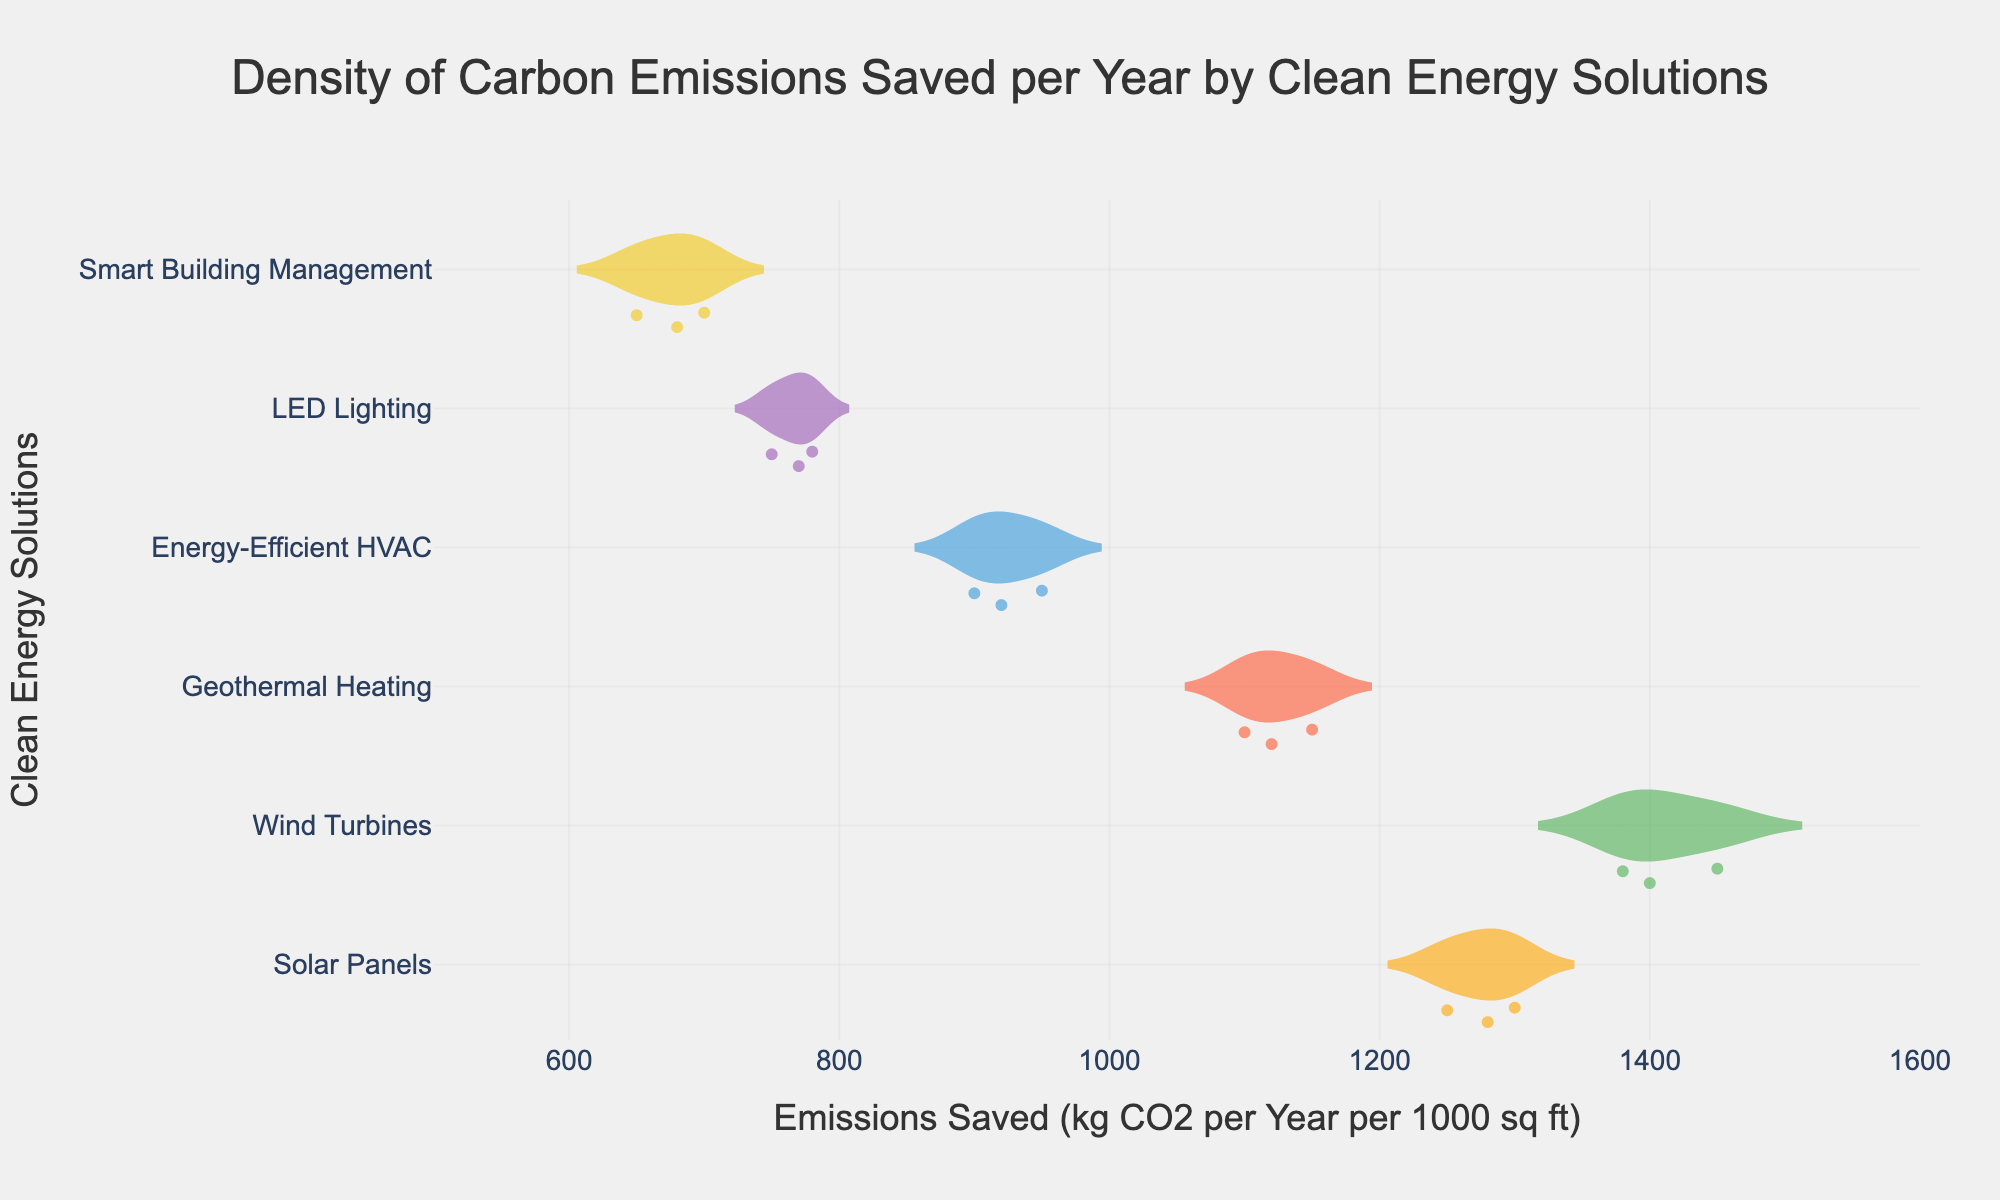What is the title of the plot? The title is typically located at the top of the plot and directly indicates what the plot represents.
Answer: Density of Carbon Emissions Saved per Year by Clean Energy Solutions Which clean energy solution appears to have the highest emissions saved per year? There are different density distributions for each solution. By visually determining the solution with the highest range of values, we see which one peaks highest on the x-axis.
Answer: Wind Turbines How does the emissions saved by LED Lighting compare to that of Smart Building Management? By comparing the range of values for the emissions saved for both solutions, we observe the distribution and mean lines.
Answer: LED Lighting generally saves more emissions than Smart Building Management Which solution has the most consistent emissions savings based on the density plots? Consistency can be inferred from the narrowness and coherence of the distribution. A narrower plot suggests less variance.
Answer: LED Lighting What is the range of emissions saved by Geothermal Heating from the data shown? The range can be deduced by looking at the minimum and maximum values in the plot specific to Geothermal Heating.
Answer: From 1100 to 1150 kg CO2 per Year per 1000 sq ft How does the emissions savings for Energy-Efficient HVAC vary? The variation can be understood by examining the spread of the density plot for this solution, denoted by its range and the distribution width.
Answer: From 900 to 950 kg CO2 per Year per 1000 sq ft Are there any clean energy solutions with less than 700 kg CO2 emissions saved? By looking at the lowest values on the x-axis across all the solutions, we check if any fall below 700 kg CO2 savings.
Answer: Yes, Smart Building Management What is the median emissions saved for Solar Panels? The median can be approximated by identifying the center of the density plot for Solar Panels.
Answer: Around 1280 kg CO2 per Year per 1000 sq ft Which clean energy solution shows the widest variation in emissions savings? The solution with the widest range on the x-axis represents the most variation.
Answer: Wind Turbines What are the colors used for each clean energy solution’s density plot? The color scheme follows specific assignments, which can be cross-verified by the legend or color coding.
Answer: Solar Panels: orange, Wind Turbines: green, Geothermal Heating: red, Energy-Efficient HVAC: blue, LED Lighting: purple, Smart Building Management: yellow 